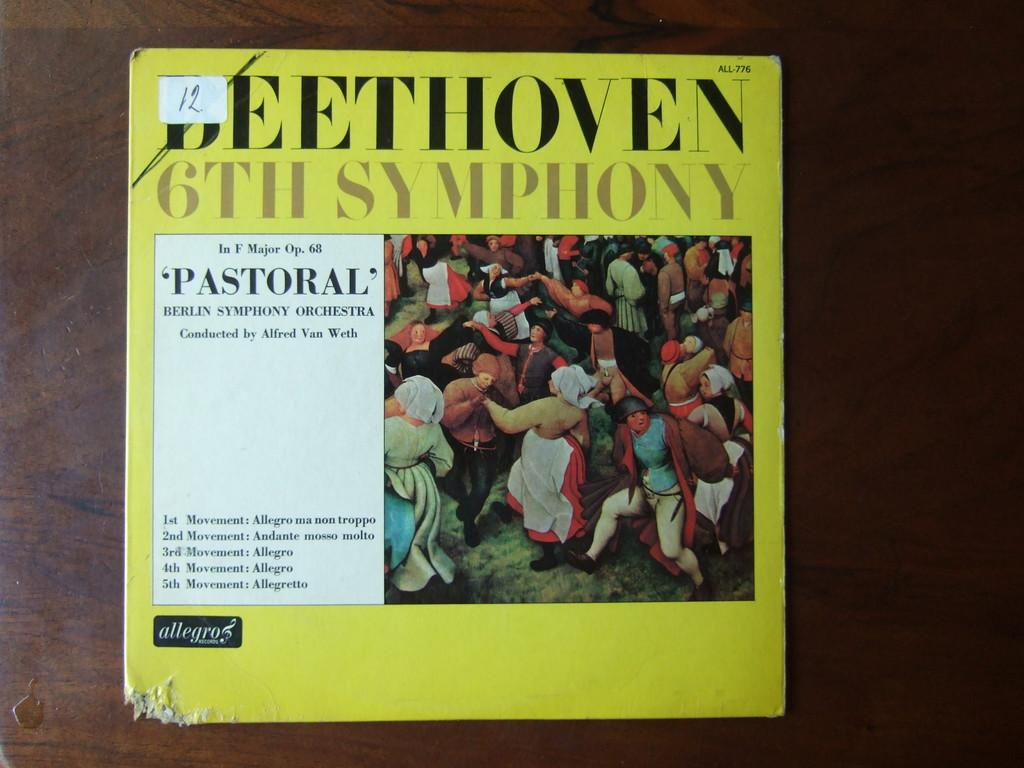<image>
Present a compact description of the photo's key features. A record album features the 6th Symphony from the composer Beethoven. 